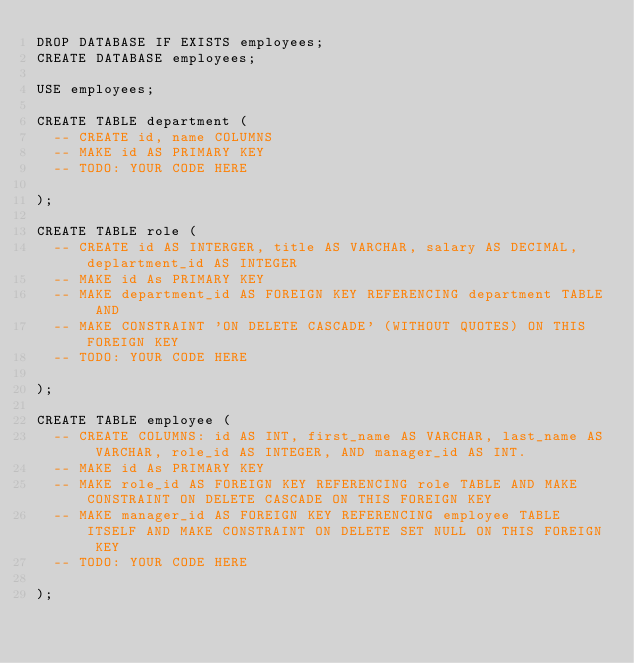Convert code to text. <code><loc_0><loc_0><loc_500><loc_500><_SQL_>DROP DATABASE IF EXISTS employees;
CREATE DATABASE employees;

USE employees;

CREATE TABLE department (
  -- CREATE id, name COLUMNS
  -- MAKE id AS PRIMARY KEY
  -- TODO: YOUR CODE HERE

);

CREATE TABLE role (
  -- CREATE id AS INTERGER, title AS VARCHAR, salary AS DECIMAL, deplartment_id AS INTEGER
  -- MAKE id As PRIMARY KEY
  -- MAKE department_id AS FOREIGN KEY REFERENCING department TABLE AND
  -- MAKE CONSTRAINT 'ON DELETE CASCADE' (WITHOUT QUOTES) ON THIS FOREIGN KEY
  -- TODO: YOUR CODE HERE

);

CREATE TABLE employee (
  -- CREATE COLUMNS: id AS INT, first_name AS VARCHAR, last_name AS VARCHAR, role_id AS INTEGER, AND manager_id AS INT.
  -- MAKE id As PRIMARY KEY
  -- MAKE role_id AS FOREIGN KEY REFERENCING role TABLE AND MAKE CONSTRAINT ON DELETE CASCADE ON THIS FOREIGN KEY
  -- MAKE manager_id AS FOREIGN KEY REFERENCING employee TABLE ITSELF AND MAKE CONSTRAINT ON DELETE SET NULL ON THIS FOREIGN KEY
  -- TODO: YOUR CODE HERE

);
</code> 